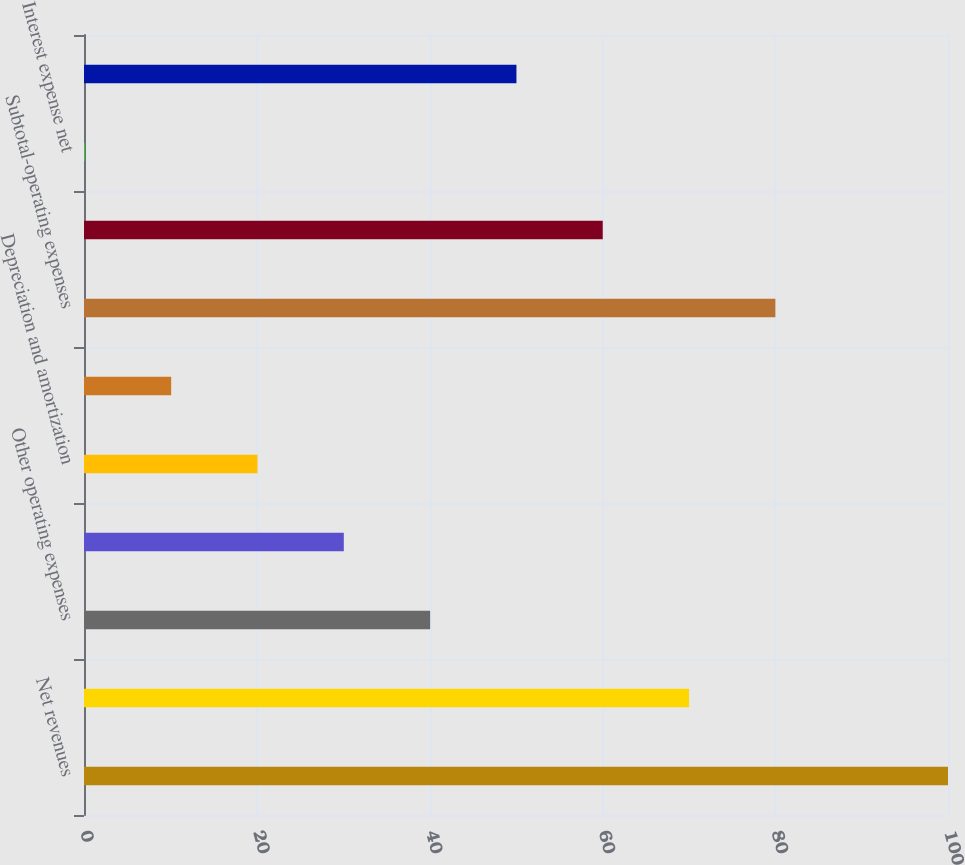<chart> <loc_0><loc_0><loc_500><loc_500><bar_chart><fcel>Net revenues<fcel>Salaries wages and benefits<fcel>Other operating expenses<fcel>Supplies expense<fcel>Depreciation and amortization<fcel>Lease and rental expense<fcel>Subtotal-operating expenses<fcel>Income from operations<fcel>Interest expense net<fcel>Income before income taxes<nl><fcel>100<fcel>70.03<fcel>40.06<fcel>30.07<fcel>20.08<fcel>10.09<fcel>80.02<fcel>60.04<fcel>0.1<fcel>50.05<nl></chart> 